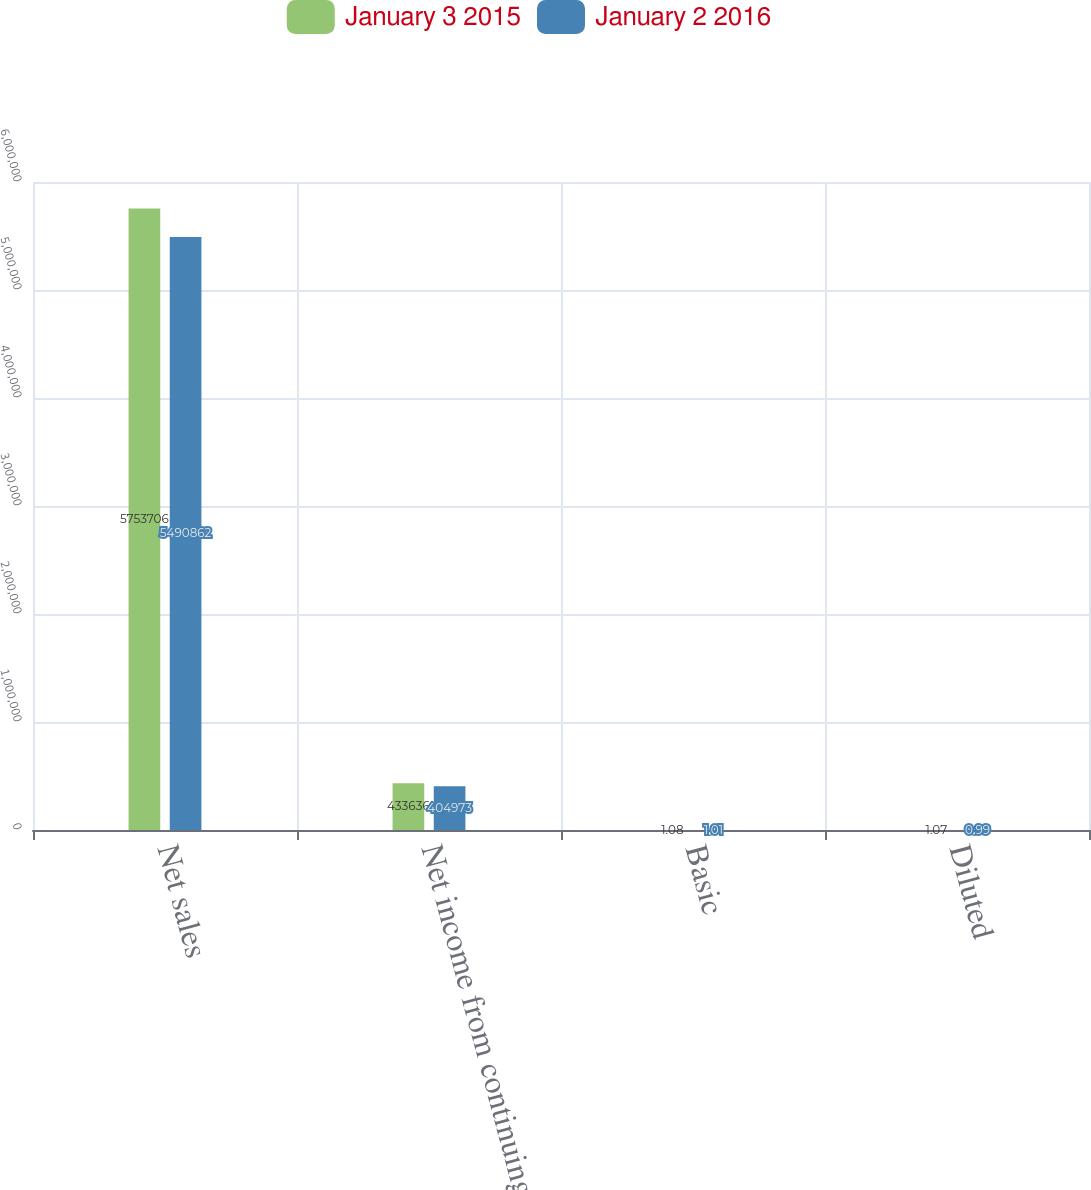Convert chart to OTSL. <chart><loc_0><loc_0><loc_500><loc_500><stacked_bar_chart><ecel><fcel>Net sales<fcel>Net income from continuing<fcel>Basic<fcel>Diluted<nl><fcel>January 3 2015<fcel>5.75371e+06<fcel>433636<fcel>1.08<fcel>1.07<nl><fcel>January 2 2016<fcel>5.49086e+06<fcel>404973<fcel>1.01<fcel>0.99<nl></chart> 